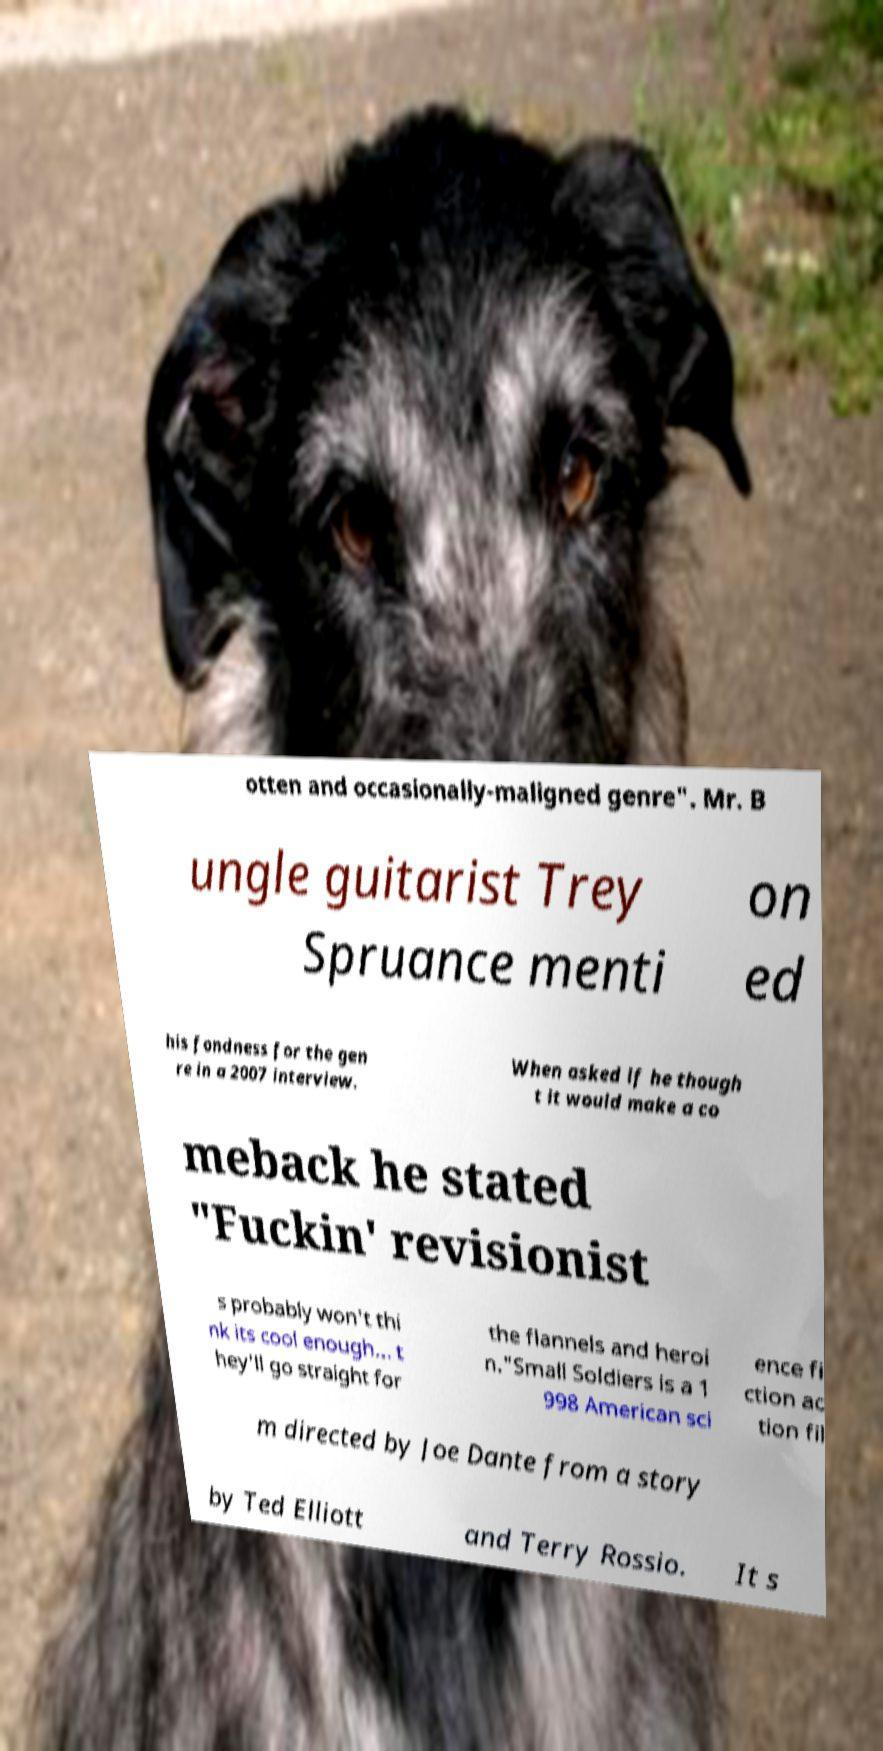Please read and relay the text visible in this image. What does it say? otten and occasionally-maligned genre". Mr. B ungle guitarist Trey Spruance menti on ed his fondness for the gen re in a 2007 interview. When asked if he though t it would make a co meback he stated "Fuckin' revisionist s probably won't thi nk its cool enough... t hey'll go straight for the flannels and heroi n."Small Soldiers is a 1 998 American sci ence fi ction ac tion fil m directed by Joe Dante from a story by Ted Elliott and Terry Rossio. It s 